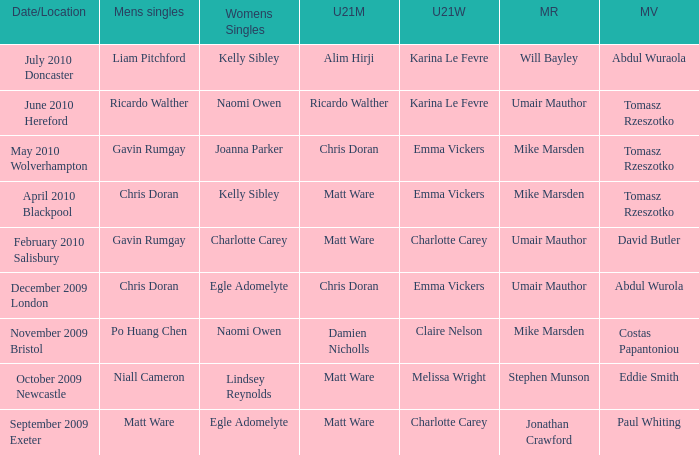When and where did Eddie Smith win the mixed veteran? 1.0. 